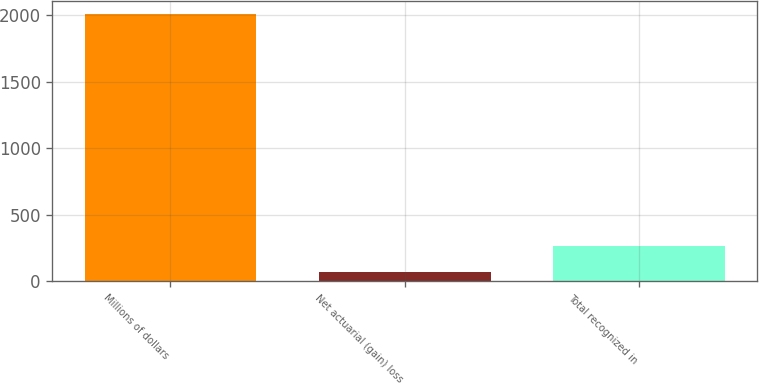Convert chart. <chart><loc_0><loc_0><loc_500><loc_500><bar_chart><fcel>Millions of dollars<fcel>Net actuarial (gain) loss<fcel>Total recognized in<nl><fcel>2007<fcel>72<fcel>265.5<nl></chart> 